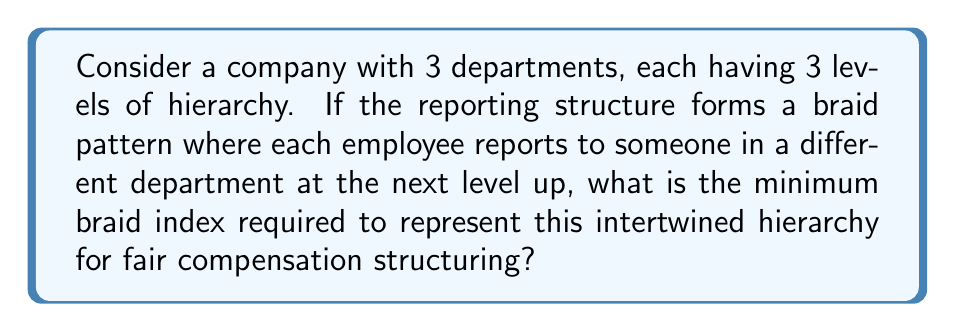Provide a solution to this math problem. To solve this problem, we'll follow these steps:

1) First, we need to understand what the braid index represents in this context. The braid index is the minimum number of strands needed to represent the braid.

2) In this case, each strand represents a reporting line from the bottom to the top of the hierarchy.

3) We have 3 departments, each with 3 levels. This means we have 9 employees in total (3 in each department).

4) Each employee reports to someone in a different department at the next level up. This creates a complex intertwining pattern.

5) To represent this pattern, we need at least one strand for each employee at the lowest level. This is because each of these employees will have a unique path to the top of the hierarchy.

6) Therefore, the minimum number of strands needed is equal to the number of employees at the lowest level.

7) In this case, there are 3 employees at the lowest level (one in each department).

Thus, the minimum braid index required to represent this intertwined hierarchy is 3.

This can be represented mathematically as:

$$\text{Braid Index} = \min(\text{number of strands}) = \text{number of employees at lowest level} = 3$$

This braid index ensures that each unique reporting path can be represented, allowing for fair compensation structuring based on the complexity of the reporting relationships.
Answer: 3 